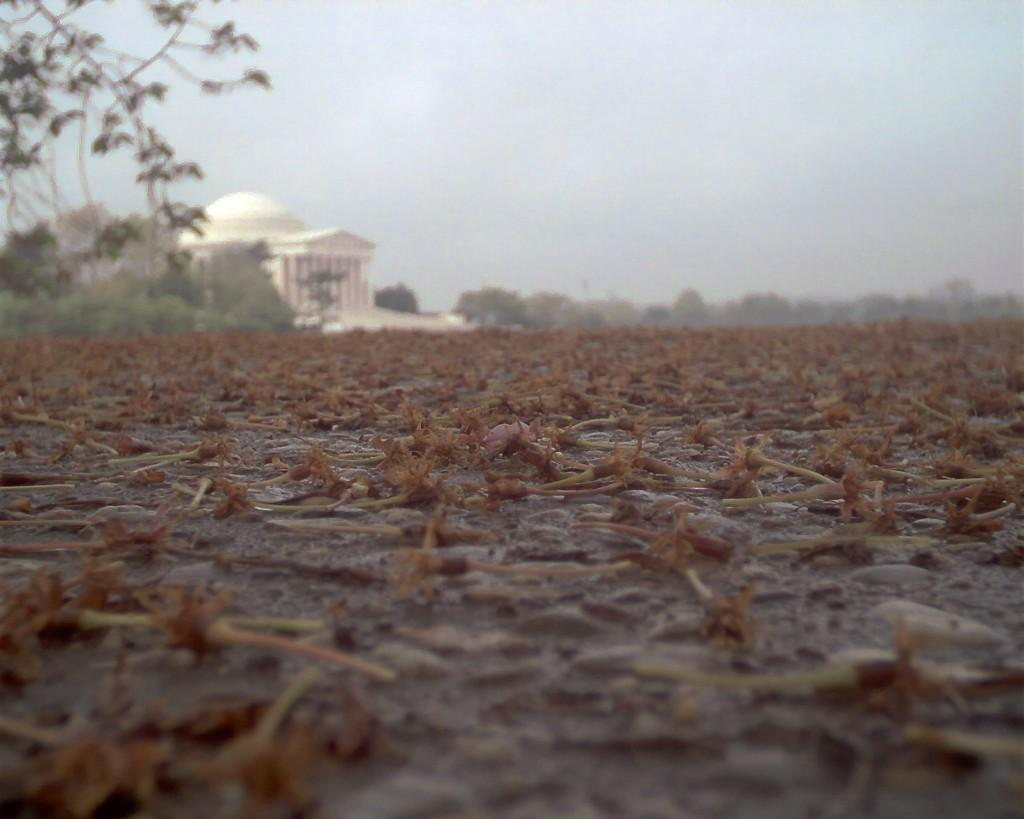What is on the ground in the image? There are dry flowers on the ground in the image. What can be seen in the background of the image? There is a building in the background of the image, and there are trees beside the building. What is visible at the top of the image? The sky is visible at the top of the image. Can you see a pencil being used to draw in the image? There is no pencil or drawing activity present in the image. 